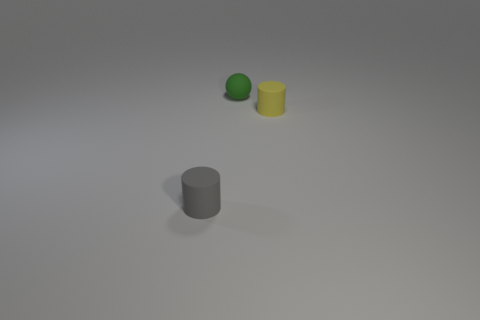Add 3 small green things. How many objects exist? 6 Subtract all balls. How many objects are left? 2 Add 2 brown metal cubes. How many brown metal cubes exist? 2 Subtract 0 cyan cylinders. How many objects are left? 3 Subtract all tiny gray things. Subtract all small yellow rubber objects. How many objects are left? 1 Add 2 small objects. How many small objects are left? 5 